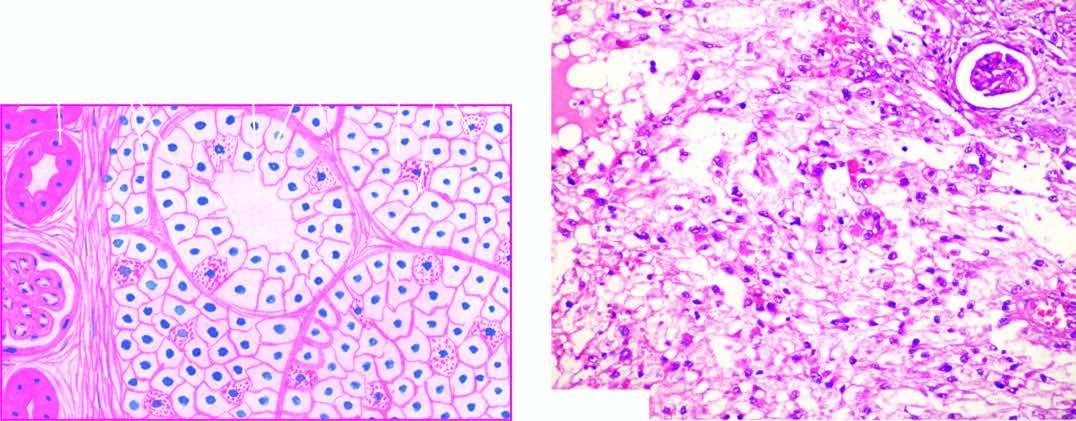what does the tumour show?
Answer the question using a single word or phrase. Solid masses and acini of uniform-appearing tumour cells 